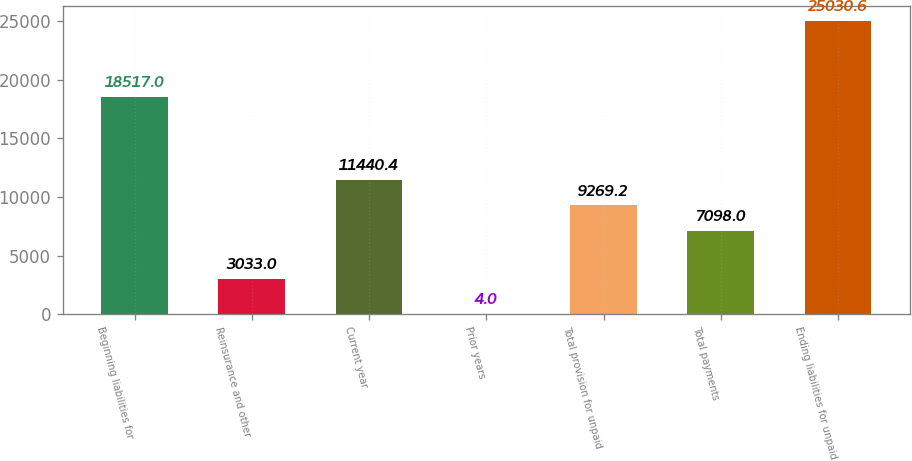Convert chart to OTSL. <chart><loc_0><loc_0><loc_500><loc_500><bar_chart><fcel>Beginning liabilities for<fcel>Reinsurance and other<fcel>Current year<fcel>Prior years<fcel>Total provision for unpaid<fcel>Total payments<fcel>Ending liabilities for unpaid<nl><fcel>18517<fcel>3033<fcel>11440.4<fcel>4<fcel>9269.2<fcel>7098<fcel>25030.6<nl></chart> 